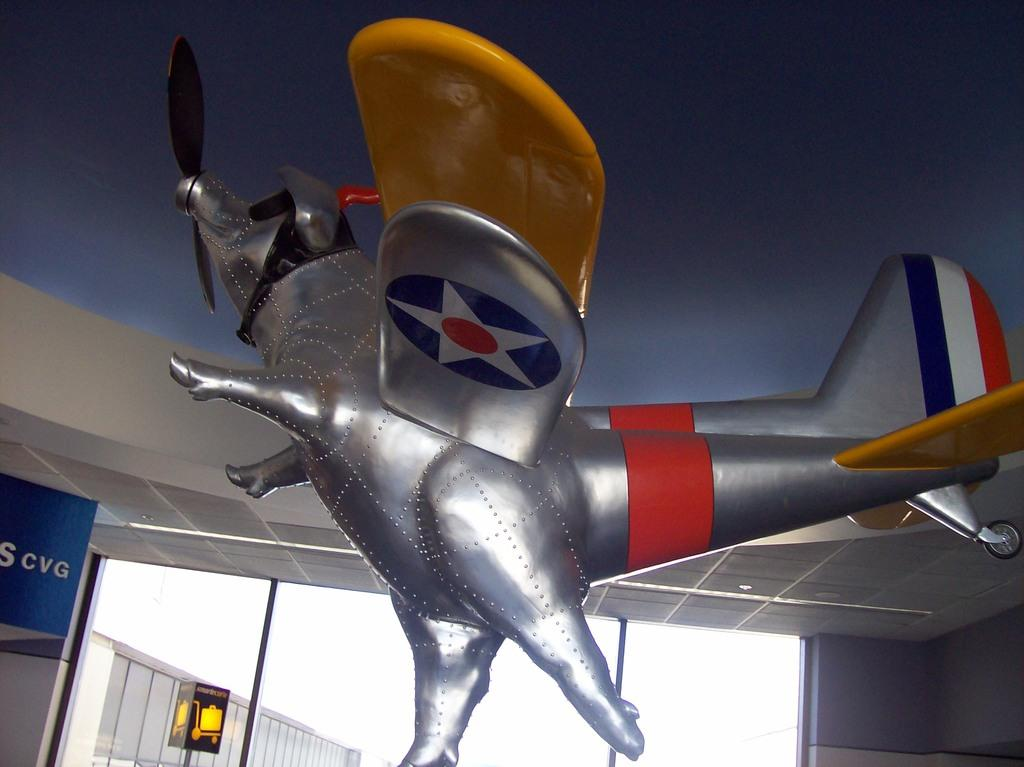What is the main subject of the image? The main subject of the image is a sculpture of a flying jet. Is there anything else connected to the sculpture? Yes, there is an animal attached to the sculpture. What type of structure can be seen in the background of the image? There is a glass window visible in the image. What is the purpose of the board in the image? The purpose of the board in the image is not clear, but it might be used for displaying information or as a support for the sculpture. What can be read or seen in the image? There is text visible in the image. What type of church can be seen in the image? There is no church present in the image; it features a sculpture of a flying jet with an attached animal, a glass window, a board, and visible text. What kind of medical advice can be obtained from the doctor in the image? There is no doctor present in the image; it features a sculpture of a flying jet with an attached animal, a glass window, a board, and visible text. 